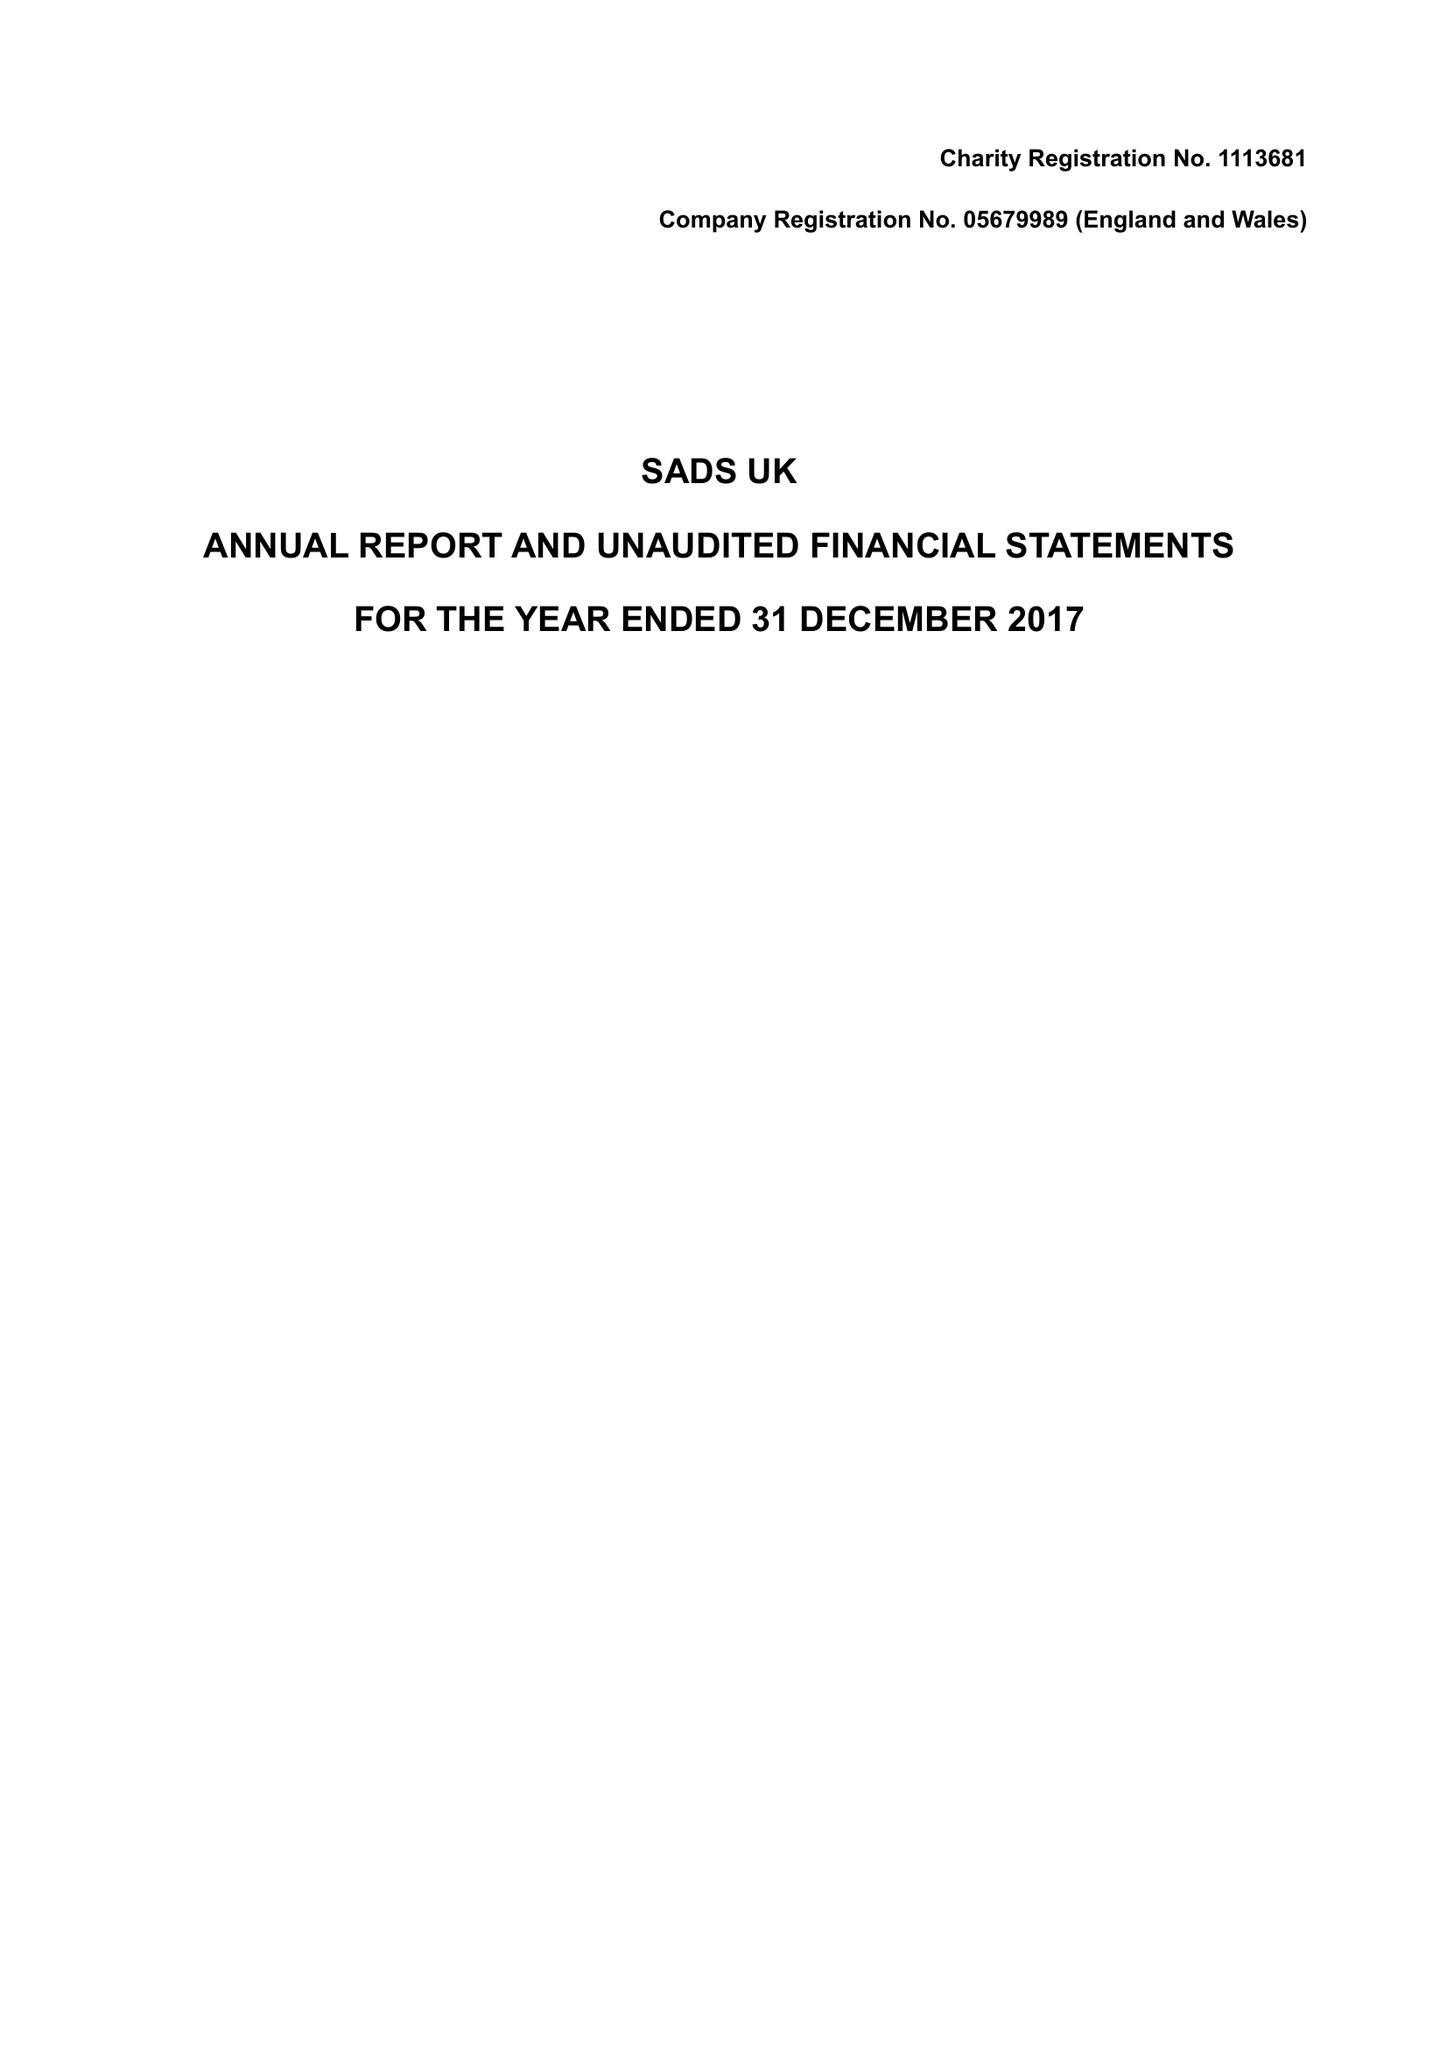What is the value for the address__postcode?
Answer the question using a single word or phrase. CM13 2TS 